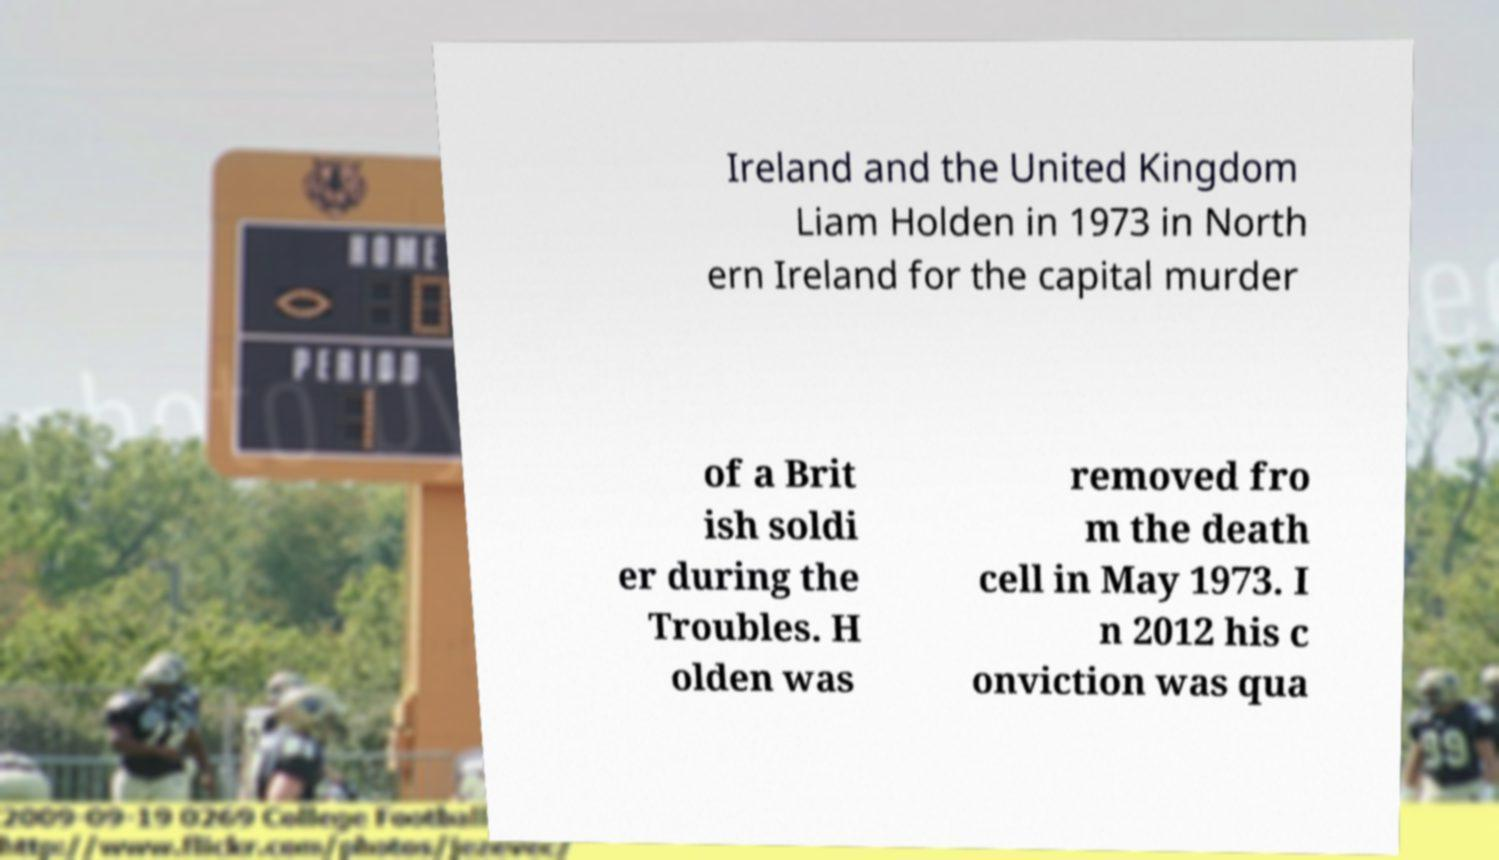Please identify and transcribe the text found in this image. Ireland and the United Kingdom Liam Holden in 1973 in North ern Ireland for the capital murder of a Brit ish soldi er during the Troubles. H olden was removed fro m the death cell in May 1973. I n 2012 his c onviction was qua 